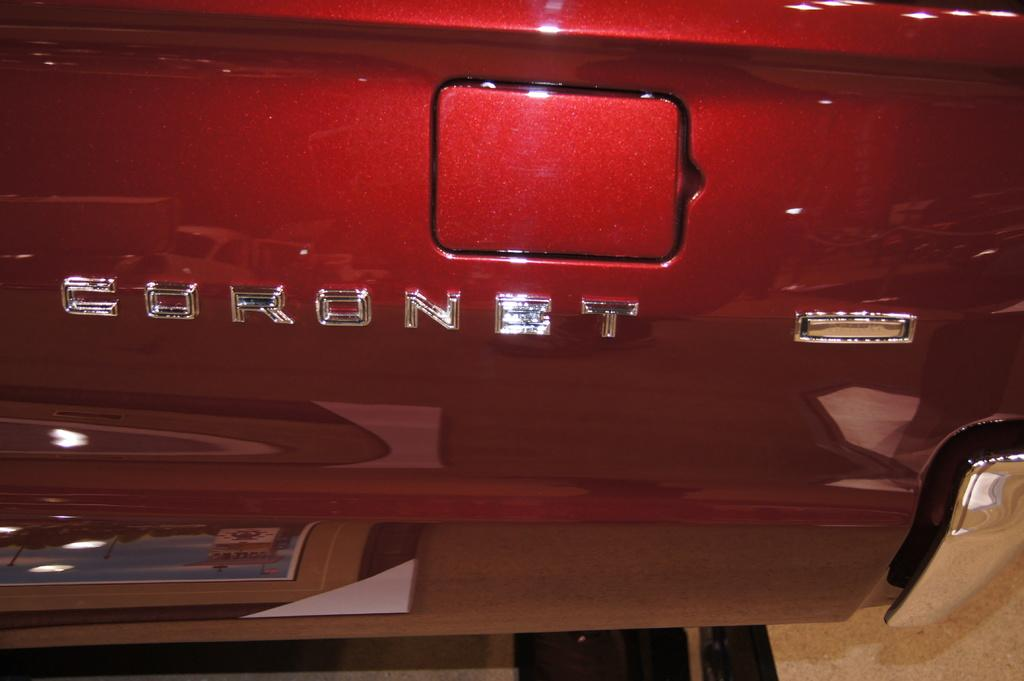What is the main subject of the image? There is a vehicle in the image. What can be said about the color of the vehicle? The vehicle is red in color. Can you describe the waves in the image? There are no waves present in the image; it features a red vehicle. What type of property is visible in the image? There is no property visible in the image; it features a red vehicle. 